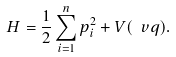<formula> <loc_0><loc_0><loc_500><loc_500>H = \frac { 1 } { 2 } \sum _ { i = 1 } ^ { n } p _ { i } ^ { 2 } + V ( \ v q ) .</formula> 